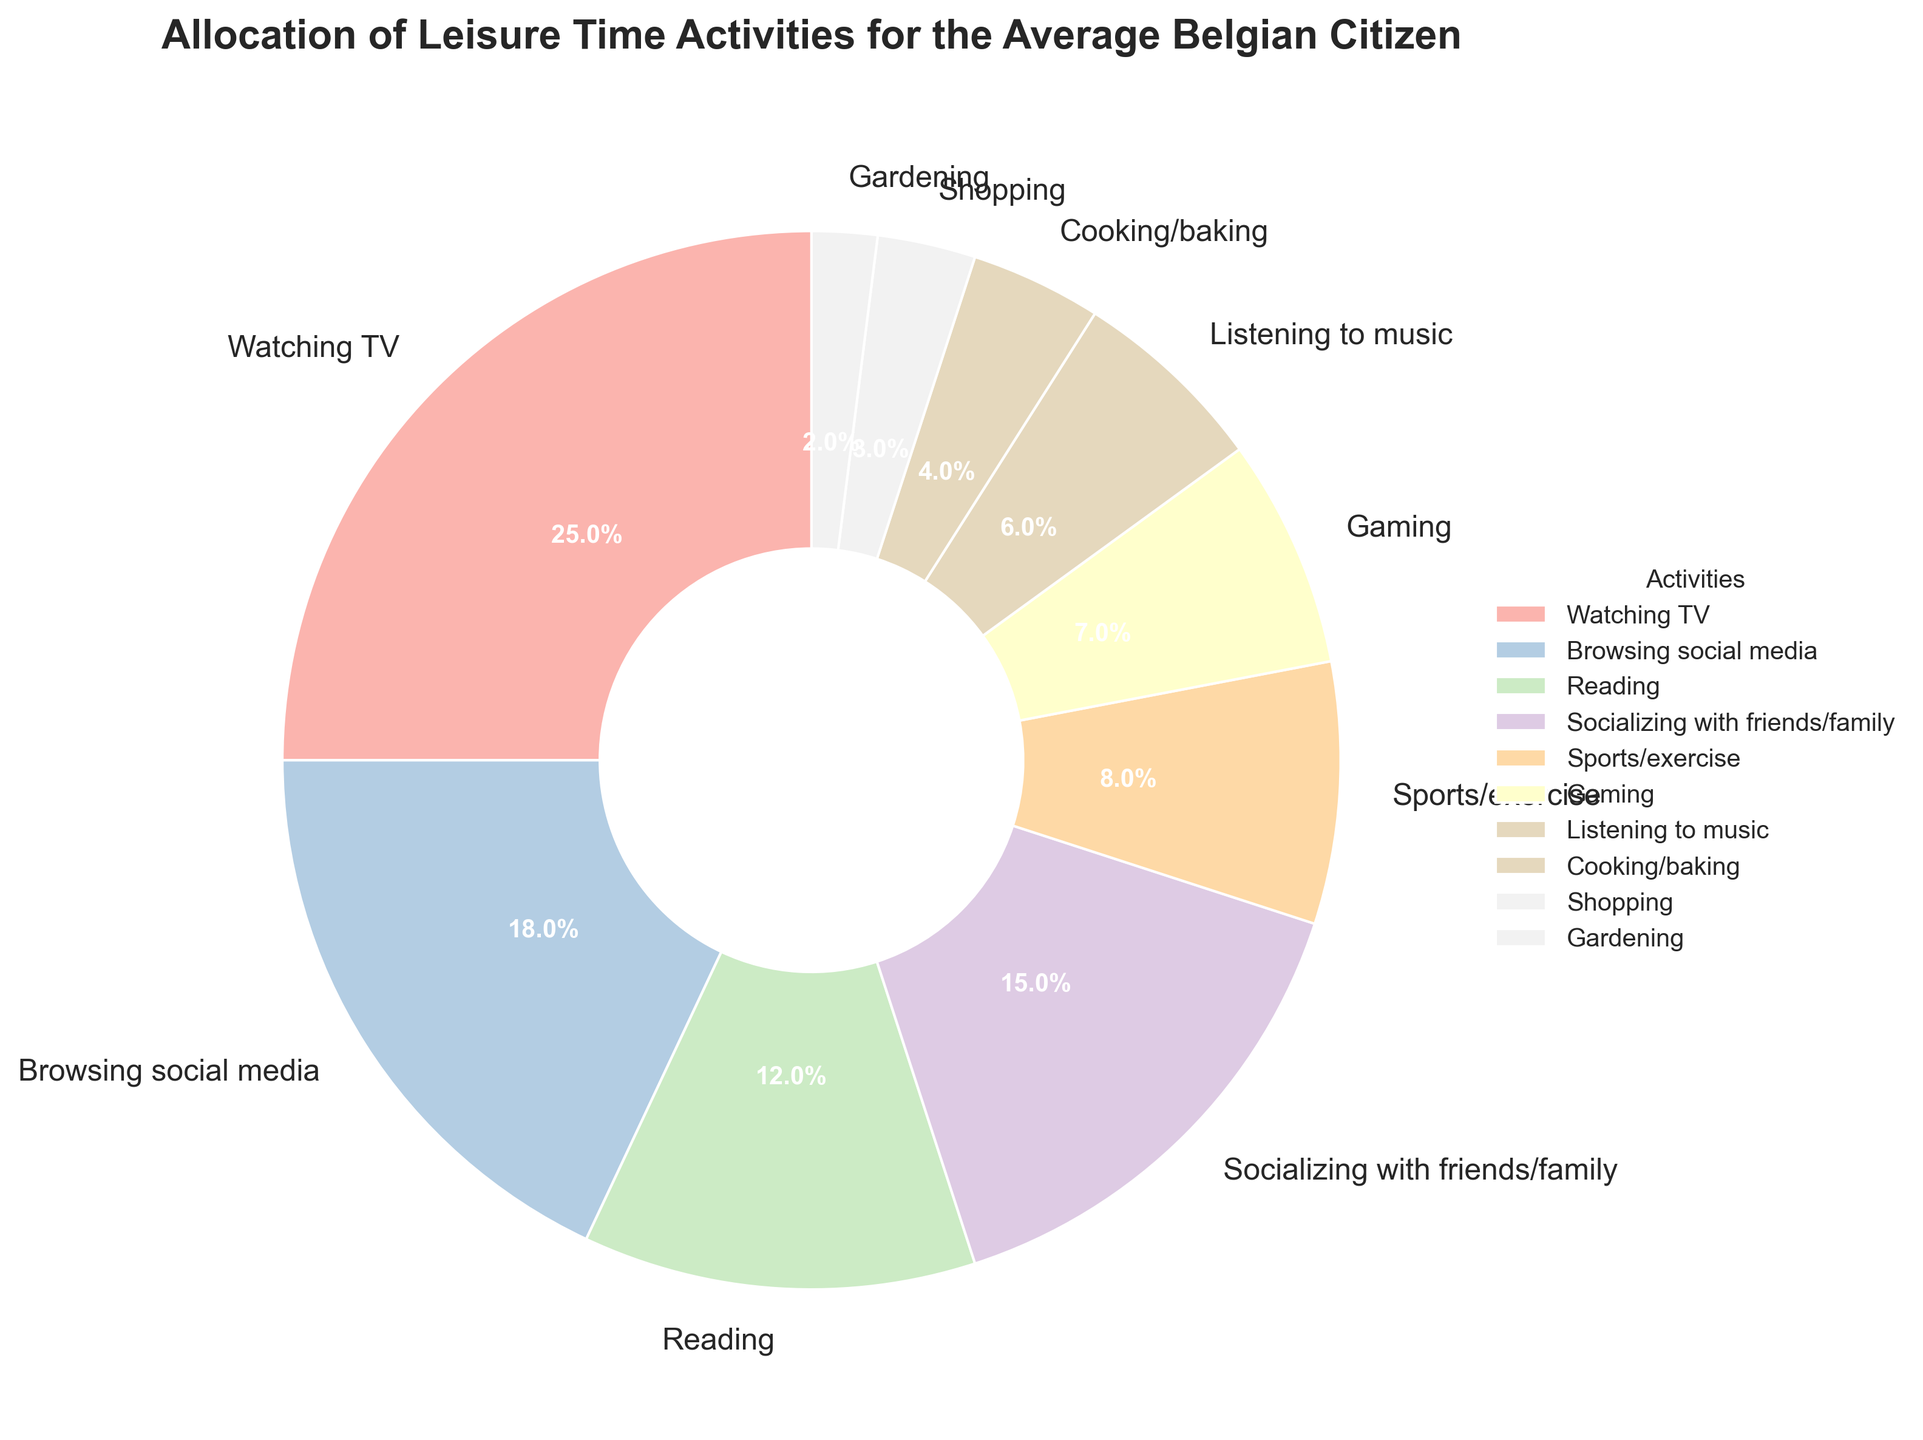What's the largest leisure time activity by percentage? The activity with the largest percentage is Watching TV, which makes up 25% of the leisure time activities.
Answer: Watching TV Which leisure activity occupies double the percentage of cooking/baking? Cooking/baking is 4%, so double that amount is 8%. The activity taking up 8% of the leisure time is Sports/exercise.
Answer: Sports/exercise How much more percentage is allocated to browsing social media than gaming? Browsing social media has 18%, while gaming has 7%. The difference is 18% - 7% = 11%.
Answer: 11% What is the combined percentage of activities related to Screen time (Watching TV, Browsing social media, Gaming)? Watching TV (25%), Browsing social media (18%), and Gaming (7%). Summing these up, 25% + 18% + 7% = 50%.
Answer: 50% Are there more leisure time activities allocated to reading or socializing with friends/family? Reading accounts for 12%, whereas socializing with friends/family accounts for 15%. 15% is greater than 12%.
Answer: Socializing with friends/family Which activity has the lowest percentage of allocated time? The activity with the least percentage is Gardening at 2%.
Answer: Gardening How much more percentage is spent on reading compared to listening to music and cooking/baking combined? Reading is at 12%. Listening to music is 6% and cooking/baking is 4%. Combined, 6% + 4% = 10%. The difference is 12% - 10% = 2%.
Answer: 2% Which activity takes up less than half the time allocated to socializing with friends/family? Socializing with friends/family is 15%. Half of that is 7.5%. Activities taking up less than 7.5% are Gaming (7%), Listening to music (6%), Cooking/baking (4%), Shopping (3%), and Gardening (2%).
Answer: Gaming, Listening to music, Cooking/baking, Shopping, Gardening What is the combined percentage of time spent on Shopping and Gardening? Shopping takes up 3%, and gardening takes up 2%. Combined, this is 3% + 2% = 5%.
Answer: 5% How much percentage do sports/exercise and gaming contribute together? Sports/exercise contributes 8%, and gaming contributes 7%. Together, this is 8% + 7% = 15%.
Answer: 15% 